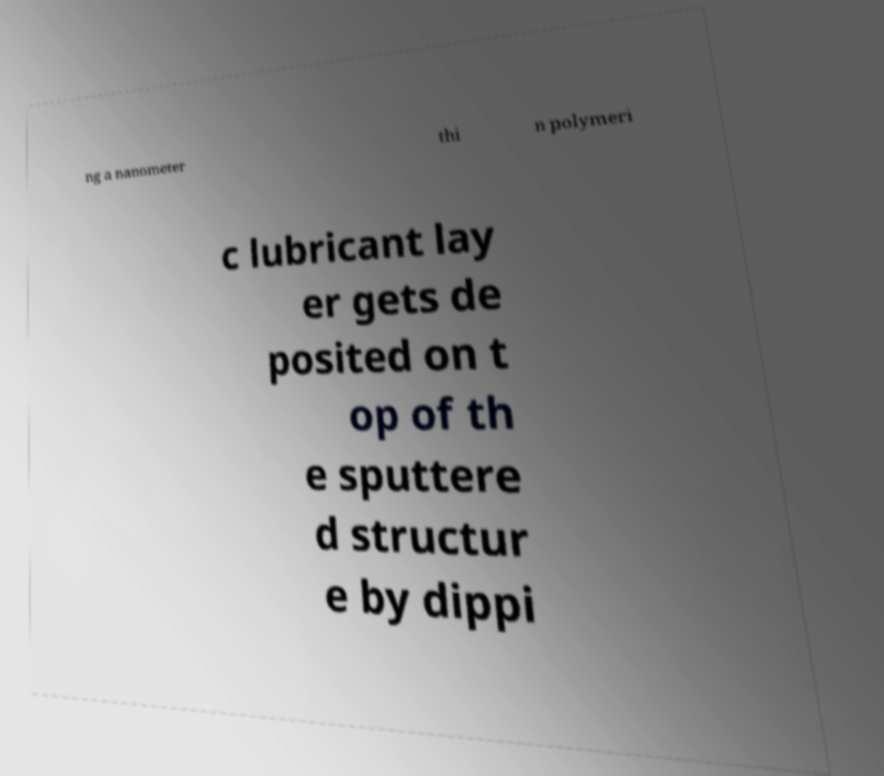Can you read and provide the text displayed in the image?This photo seems to have some interesting text. Can you extract and type it out for me? ng a nanometer thi n polymeri c lubricant lay er gets de posited on t op of th e sputtere d structur e by dippi 